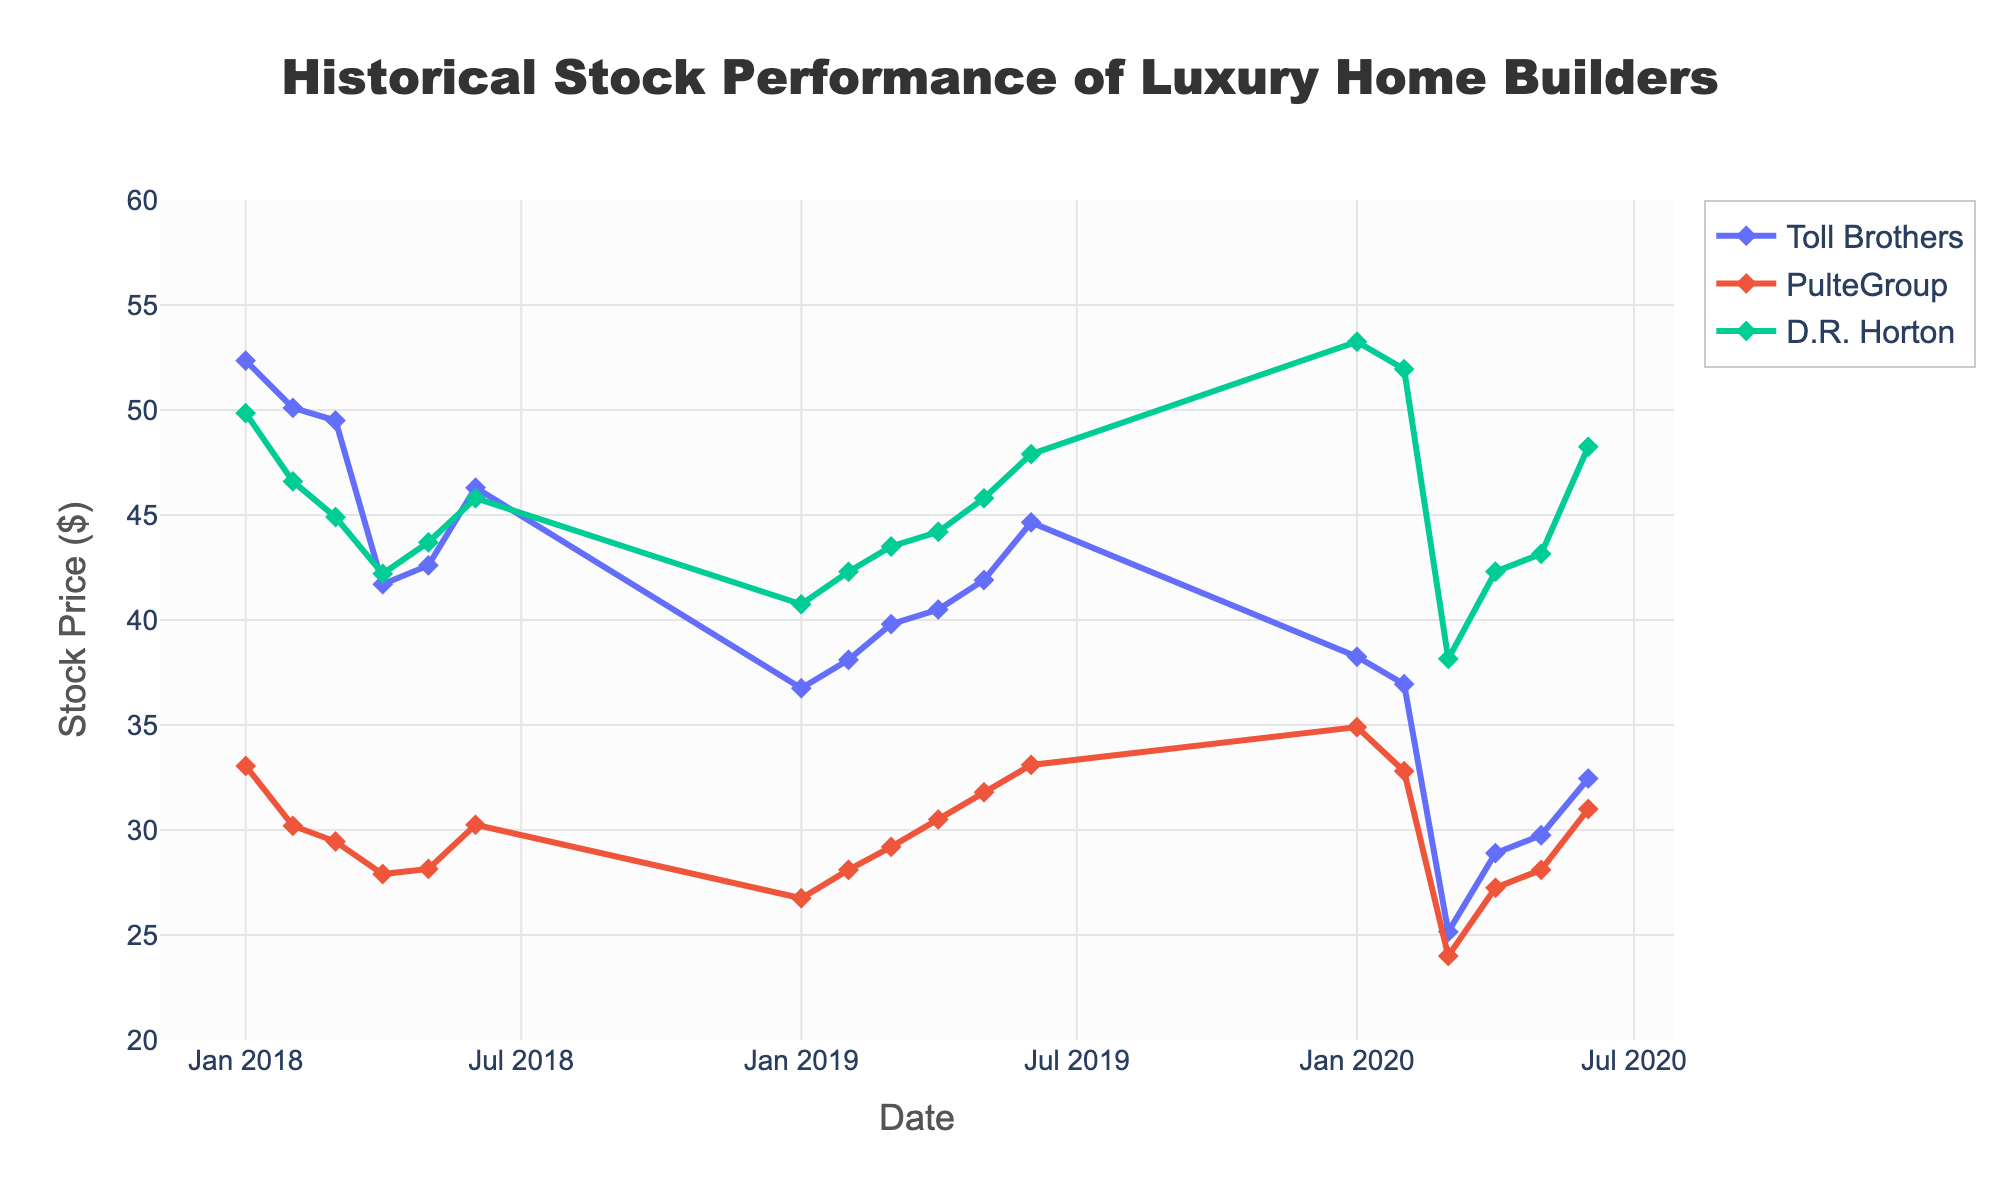What is the title of the plot? The title is text displayed at the top of the figure. The title is positioned centrally and reads 'Historical Stock Performance of Luxury Home Builders'. This can be directly observed from the figure.
Answer: Historical Stock Performance of Luxury Home Builders How many companies' stock performances are shown in the plot? The legend at the right side of the plot lists the companies. There are three entries in the legend, which correspond to three companies.
Answer: 3 What was the highest stock price recorded for Toll Brothers in 2018? The stock prices for Toll Brothers in 2018 can be observed from the lines and markers corresponding to Toll Brothers on the x-axis between January 2018 and December 2018. The highest price observed for Toll Brothers in this timeframe is 52.35.
Answer: 52.35 How did PulteGroup's stock price change from January 2019 to June 2019? To find this, look at PulteGroup's markers from January 2019 to June 2019. At the start of January, the price is 26.75, and it increases progressively to 33.10 in June. This reveals an overall increase.
Answer: Increased from 26.75 to 33.10 Between Toll Brothers and D.R. Horton, which company had a higher stock price in March 2020? According to the plot markers in March 2020, Toll Brothers' stock price was 25.15 and D.R. Horton's price was 38.15. Comparing these, D.R. Horton had the higher price.
Answer: D.R. Horton What is the range of the y-axis? The y-axis range is marked with a start and end value which bounds the data. It starts at 20 and ends at 60.
Answer: 20 to 60 Which company had the steepest decline in stock price in the first half of 2020? Examine the slopes of the lines for each company from January 2020 to June 2020. Of the three companies, Toll Brothers had a drop from 38.25 to 25.15 by March which is the steepest decline.
Answer: Toll Brothers What is the average stock price of D.R. Horton in 2018? To find the average, add D.R. Horton's stock prices for each month in 2018 (49.85 + 46.60 + 44.90 + 42.20 + 43.70 + 45.80), then divide by the number of months, which is 6. The sum is 273.05, so average is 273.05/6 = 45.51.
Answer: 45.51 Compare the trend in stock prices for PulteGroup in the first six months of 2019 to the first six months of 2020. For 2019, PulteGroup's stock shows a rising trend from 26.75 in January to 33.10 in June. For 2020, it shows more fluctuation, dropping from 34.90 in January to 24.00 in March, then rising back to 31.00 by June. Overall, 2019 had a steady increase while 2020 had significant fluctuations.
Answer: 2019: rising, 2020: fluctuating How did D.R. Horton's stock price change in April 2020? Examining D.R. Horton's stock price markers specifically in the month of April 2020, it rose from 42.30 at the beginning of the month to end at 48.25 in June.
Answer: Rose from 42.30 to 48.25 